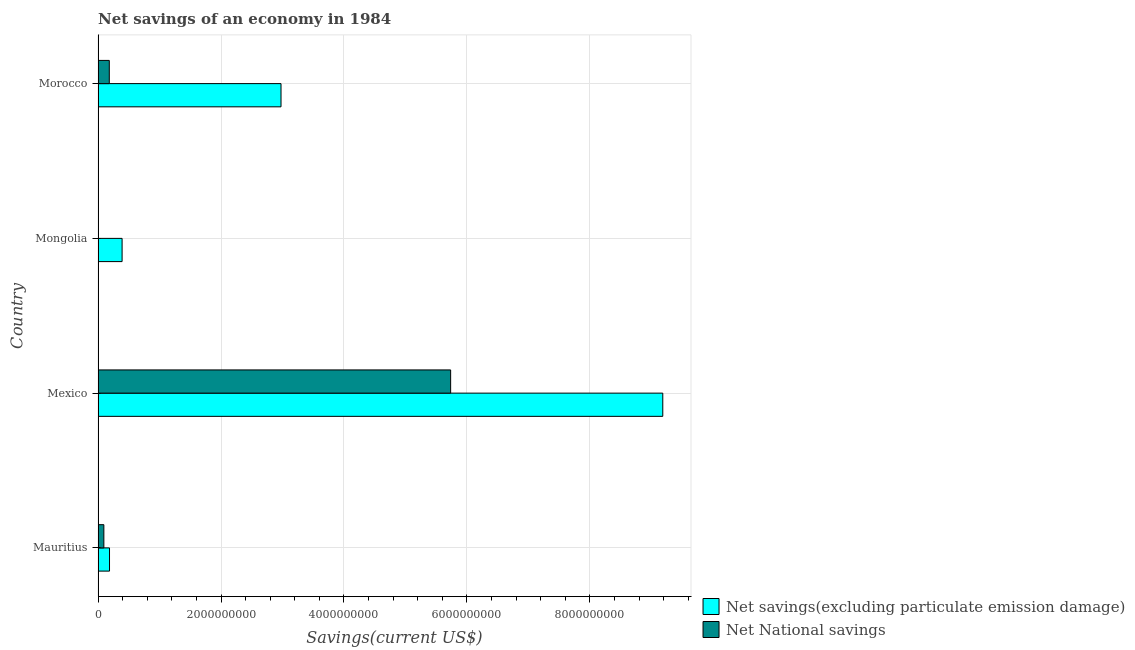How many different coloured bars are there?
Make the answer very short. 2. Are the number of bars per tick equal to the number of legend labels?
Make the answer very short. No. Are the number of bars on each tick of the Y-axis equal?
Provide a short and direct response. No. How many bars are there on the 2nd tick from the bottom?
Keep it short and to the point. 2. What is the label of the 4th group of bars from the top?
Your answer should be very brief. Mauritius. In how many cases, is the number of bars for a given country not equal to the number of legend labels?
Keep it short and to the point. 1. What is the net savings(excluding particulate emission damage) in Mexico?
Your answer should be compact. 9.19e+09. Across all countries, what is the maximum net savings(excluding particulate emission damage)?
Provide a short and direct response. 9.19e+09. Across all countries, what is the minimum net savings(excluding particulate emission damage)?
Your response must be concise. 1.87e+08. What is the total net savings(excluding particulate emission damage) in the graph?
Your answer should be very brief. 1.27e+1. What is the difference between the net national savings in Mauritius and that in Morocco?
Offer a terse response. -8.85e+07. What is the difference between the net national savings in Mexico and the net savings(excluding particulate emission damage) in Morocco?
Your answer should be very brief. 2.76e+09. What is the average net savings(excluding particulate emission damage) per country?
Provide a succinct answer. 3.18e+09. What is the difference between the net savings(excluding particulate emission damage) and net national savings in Mauritius?
Offer a terse response. 9.22e+07. What is the ratio of the net savings(excluding particulate emission damage) in Mongolia to that in Morocco?
Your response must be concise. 0.13. Is the difference between the net national savings in Mauritius and Morocco greater than the difference between the net savings(excluding particulate emission damage) in Mauritius and Morocco?
Ensure brevity in your answer.  Yes. What is the difference between the highest and the second highest net savings(excluding particulate emission damage)?
Offer a very short reply. 6.21e+09. What is the difference between the highest and the lowest net savings(excluding particulate emission damage)?
Your answer should be very brief. 9.00e+09. Is the sum of the net savings(excluding particulate emission damage) in Mexico and Morocco greater than the maximum net national savings across all countries?
Your response must be concise. Yes. How many bars are there?
Ensure brevity in your answer.  7. Are all the bars in the graph horizontal?
Make the answer very short. Yes. How many countries are there in the graph?
Provide a short and direct response. 4. What is the difference between two consecutive major ticks on the X-axis?
Provide a short and direct response. 2.00e+09. Does the graph contain grids?
Your answer should be very brief. Yes. How are the legend labels stacked?
Keep it short and to the point. Vertical. What is the title of the graph?
Ensure brevity in your answer.  Net savings of an economy in 1984. What is the label or title of the X-axis?
Provide a short and direct response. Savings(current US$). What is the label or title of the Y-axis?
Make the answer very short. Country. What is the Savings(current US$) in Net savings(excluding particulate emission damage) in Mauritius?
Keep it short and to the point. 1.87e+08. What is the Savings(current US$) in Net National savings in Mauritius?
Offer a terse response. 9.44e+07. What is the Savings(current US$) in Net savings(excluding particulate emission damage) in Mexico?
Offer a terse response. 9.19e+09. What is the Savings(current US$) of Net National savings in Mexico?
Your answer should be compact. 5.74e+09. What is the Savings(current US$) of Net savings(excluding particulate emission damage) in Mongolia?
Offer a very short reply. 3.91e+08. What is the Savings(current US$) in Net savings(excluding particulate emission damage) in Morocco?
Provide a succinct answer. 2.98e+09. What is the Savings(current US$) in Net National savings in Morocco?
Give a very brief answer. 1.83e+08. Across all countries, what is the maximum Savings(current US$) of Net savings(excluding particulate emission damage)?
Keep it short and to the point. 9.19e+09. Across all countries, what is the maximum Savings(current US$) in Net National savings?
Your response must be concise. 5.74e+09. Across all countries, what is the minimum Savings(current US$) in Net savings(excluding particulate emission damage)?
Give a very brief answer. 1.87e+08. Across all countries, what is the minimum Savings(current US$) in Net National savings?
Offer a very short reply. 0. What is the total Savings(current US$) of Net savings(excluding particulate emission damage) in the graph?
Offer a terse response. 1.27e+1. What is the total Savings(current US$) of Net National savings in the graph?
Your answer should be compact. 6.01e+09. What is the difference between the Savings(current US$) in Net savings(excluding particulate emission damage) in Mauritius and that in Mexico?
Offer a very short reply. -9.00e+09. What is the difference between the Savings(current US$) in Net National savings in Mauritius and that in Mexico?
Your answer should be compact. -5.64e+09. What is the difference between the Savings(current US$) in Net savings(excluding particulate emission damage) in Mauritius and that in Mongolia?
Provide a short and direct response. -2.05e+08. What is the difference between the Savings(current US$) of Net savings(excluding particulate emission damage) in Mauritius and that in Morocco?
Give a very brief answer. -2.79e+09. What is the difference between the Savings(current US$) of Net National savings in Mauritius and that in Morocco?
Give a very brief answer. -8.85e+07. What is the difference between the Savings(current US$) in Net savings(excluding particulate emission damage) in Mexico and that in Mongolia?
Give a very brief answer. 8.79e+09. What is the difference between the Savings(current US$) of Net savings(excluding particulate emission damage) in Mexico and that in Morocco?
Keep it short and to the point. 6.21e+09. What is the difference between the Savings(current US$) in Net National savings in Mexico and that in Morocco?
Offer a very short reply. 5.55e+09. What is the difference between the Savings(current US$) in Net savings(excluding particulate emission damage) in Mongolia and that in Morocco?
Give a very brief answer. -2.58e+09. What is the difference between the Savings(current US$) of Net savings(excluding particulate emission damage) in Mauritius and the Savings(current US$) of Net National savings in Mexico?
Your response must be concise. -5.55e+09. What is the difference between the Savings(current US$) of Net savings(excluding particulate emission damage) in Mauritius and the Savings(current US$) of Net National savings in Morocco?
Offer a terse response. 3.69e+06. What is the difference between the Savings(current US$) of Net savings(excluding particulate emission damage) in Mexico and the Savings(current US$) of Net National savings in Morocco?
Ensure brevity in your answer.  9.00e+09. What is the difference between the Savings(current US$) of Net savings(excluding particulate emission damage) in Mongolia and the Savings(current US$) of Net National savings in Morocco?
Keep it short and to the point. 2.08e+08. What is the average Savings(current US$) in Net savings(excluding particulate emission damage) per country?
Give a very brief answer. 3.18e+09. What is the average Savings(current US$) of Net National savings per country?
Your response must be concise. 1.50e+09. What is the difference between the Savings(current US$) in Net savings(excluding particulate emission damage) and Savings(current US$) in Net National savings in Mauritius?
Offer a very short reply. 9.22e+07. What is the difference between the Savings(current US$) in Net savings(excluding particulate emission damage) and Savings(current US$) in Net National savings in Mexico?
Keep it short and to the point. 3.45e+09. What is the difference between the Savings(current US$) in Net savings(excluding particulate emission damage) and Savings(current US$) in Net National savings in Morocco?
Keep it short and to the point. 2.79e+09. What is the ratio of the Savings(current US$) in Net savings(excluding particulate emission damage) in Mauritius to that in Mexico?
Provide a short and direct response. 0.02. What is the ratio of the Savings(current US$) in Net National savings in Mauritius to that in Mexico?
Your answer should be very brief. 0.02. What is the ratio of the Savings(current US$) in Net savings(excluding particulate emission damage) in Mauritius to that in Mongolia?
Ensure brevity in your answer.  0.48. What is the ratio of the Savings(current US$) in Net savings(excluding particulate emission damage) in Mauritius to that in Morocco?
Your response must be concise. 0.06. What is the ratio of the Savings(current US$) in Net National savings in Mauritius to that in Morocco?
Provide a short and direct response. 0.52. What is the ratio of the Savings(current US$) in Net savings(excluding particulate emission damage) in Mexico to that in Mongolia?
Keep it short and to the point. 23.48. What is the ratio of the Savings(current US$) in Net savings(excluding particulate emission damage) in Mexico to that in Morocco?
Ensure brevity in your answer.  3.09. What is the ratio of the Savings(current US$) in Net National savings in Mexico to that in Morocco?
Provide a short and direct response. 31.35. What is the ratio of the Savings(current US$) of Net savings(excluding particulate emission damage) in Mongolia to that in Morocco?
Keep it short and to the point. 0.13. What is the difference between the highest and the second highest Savings(current US$) of Net savings(excluding particulate emission damage)?
Provide a succinct answer. 6.21e+09. What is the difference between the highest and the second highest Savings(current US$) of Net National savings?
Provide a short and direct response. 5.55e+09. What is the difference between the highest and the lowest Savings(current US$) in Net savings(excluding particulate emission damage)?
Ensure brevity in your answer.  9.00e+09. What is the difference between the highest and the lowest Savings(current US$) of Net National savings?
Make the answer very short. 5.74e+09. 